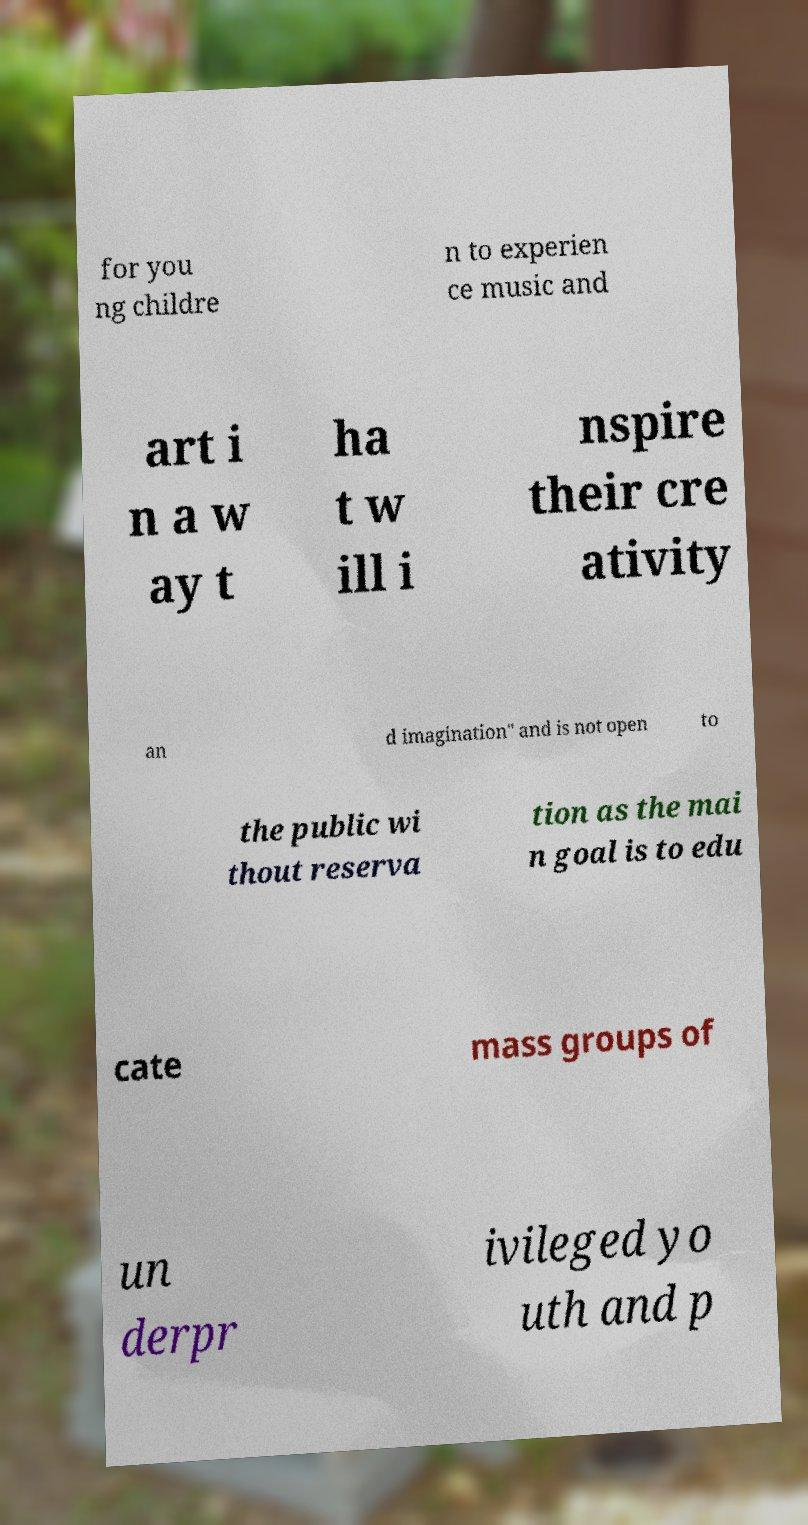Could you assist in decoding the text presented in this image and type it out clearly? for you ng childre n to experien ce music and art i n a w ay t ha t w ill i nspire their cre ativity an d imagination" and is not open to the public wi thout reserva tion as the mai n goal is to edu cate mass groups of un derpr ivileged yo uth and p 